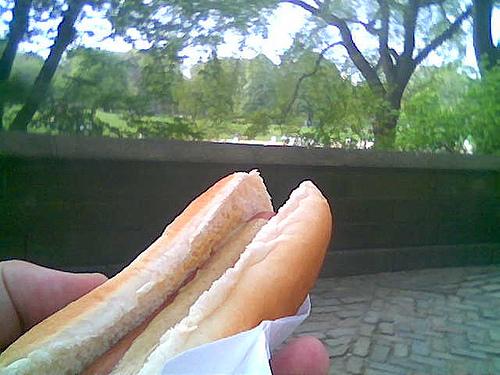Is that the strangest hot dog ever?
Give a very brief answer. No. Sunny or overcast?
Give a very brief answer. Sunny. Is the man holding the food in his left or right hand?
Short answer required. Left. What kind of food is in the man's hand?
Keep it brief. Hot dog. 